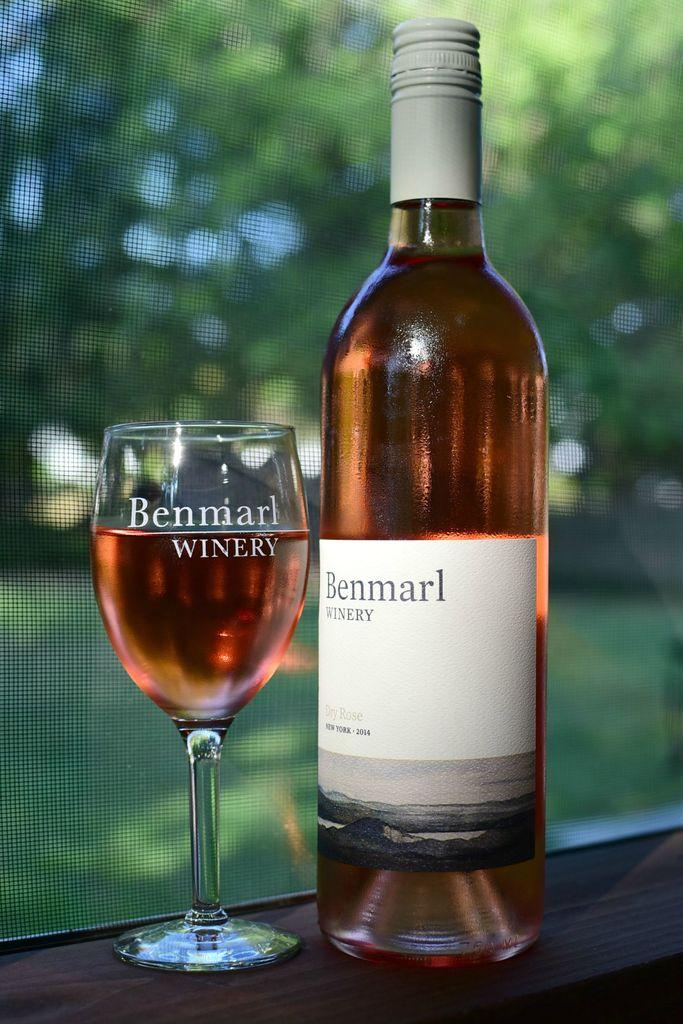What is on the bottle that is visible in the image? There is a sticker on the bottle in the image. Where is the bottle located in the image? The bottle is placed on a table in the image. What is in the glass that is visible in the image? There is a drink in the glass in the image. Where is the glass located in the image? The glass is placed on a table in the image. What can be seen in the background of the image? There is a tree and grass visible in the background of the image. How many cherries are on the basketball in the image? There is no basketball or cherries present in the image. 